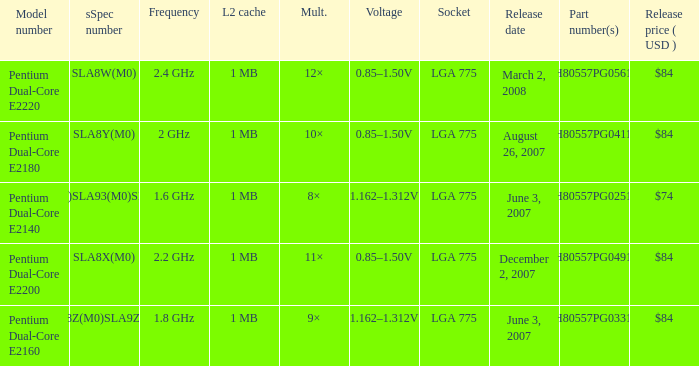What's the release price (USD) for part number hh80557pg0491m? $84. 